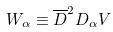Convert formula to latex. <formula><loc_0><loc_0><loc_500><loc_500>W _ { \alpha } \equiv \overline { D } ^ { 2 } D _ { \alpha } V</formula> 